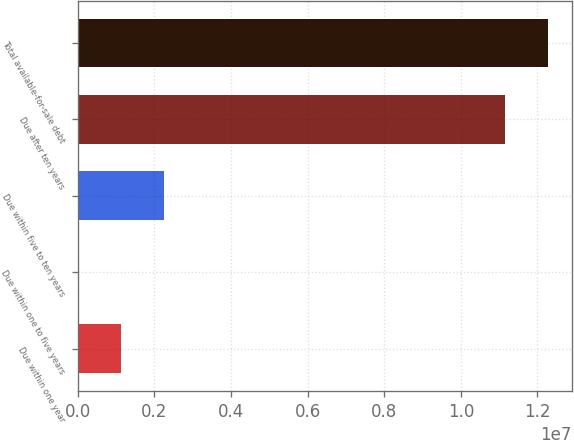Convert chart. <chart><loc_0><loc_0><loc_500><loc_500><bar_chart><fcel>Due within one year<fcel>Due within one to five years<fcel>Due within five to ten years<fcel>Due after ten years<fcel>Total available-for-sale debt<nl><fcel>1.12493e+06<fcel>488<fcel>2.24938e+06<fcel>1.11542e+07<fcel>1.22787e+07<nl></chart> 